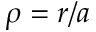<formula> <loc_0><loc_0><loc_500><loc_500>\rho = r / a</formula> 